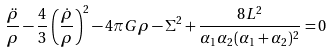Convert formula to latex. <formula><loc_0><loc_0><loc_500><loc_500>\frac { \ddot { \rho } } { \rho } - \frac { 4 } { 3 } \left ( \frac { \dot { \rho } } { \rho } \right ) ^ { 2 } - 4 \pi G \rho - \Sigma ^ { 2 } + \frac { 8 L ^ { 2 } } { \alpha _ { 1 } \alpha _ { 2 } ( \alpha _ { 1 } + \alpha _ { 2 } ) ^ { 2 } } = 0</formula> 